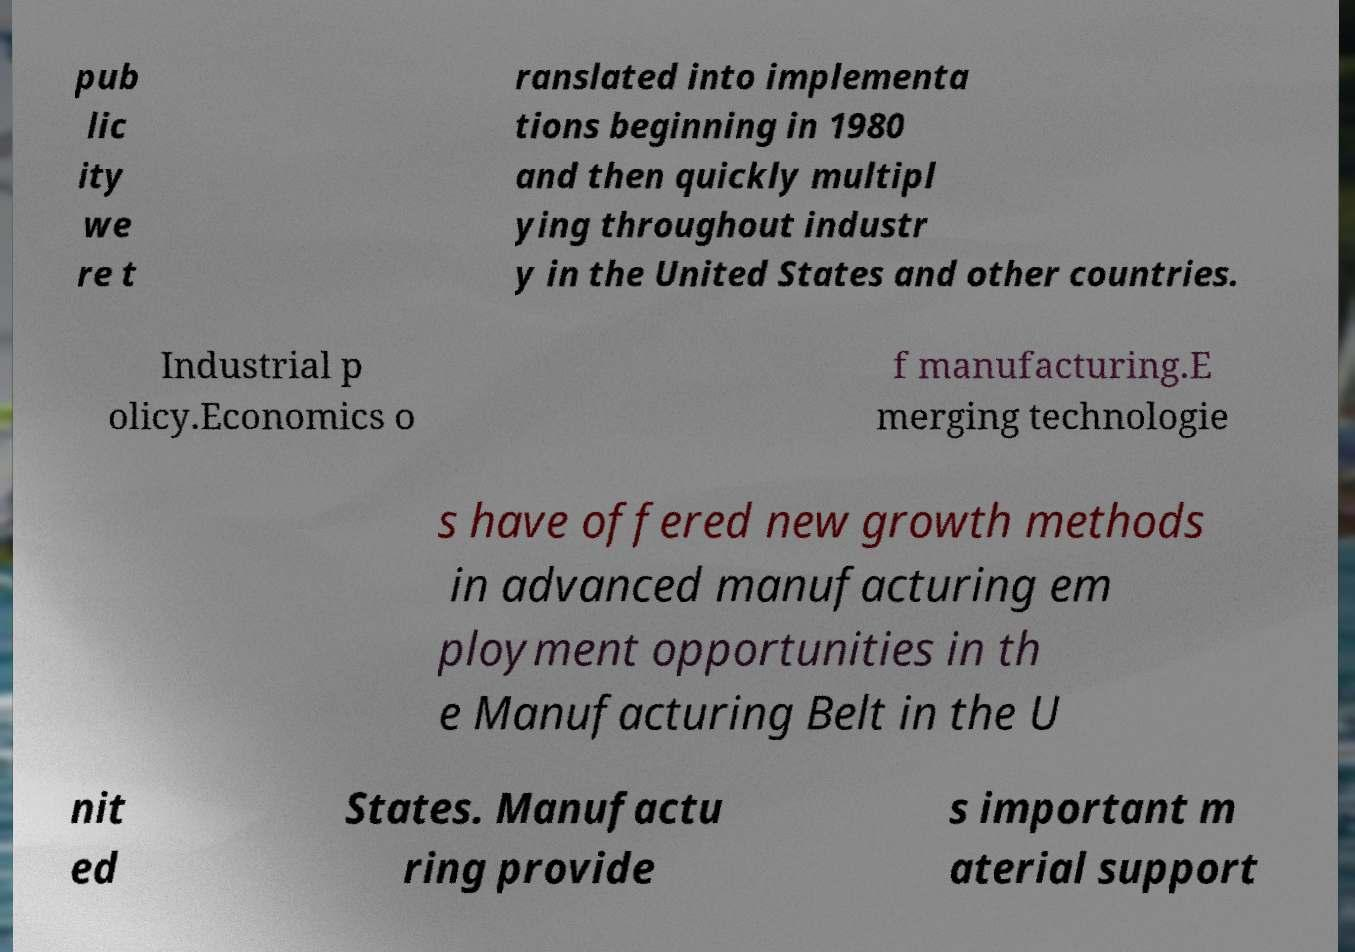Please identify and transcribe the text found in this image. pub lic ity we re t ranslated into implementa tions beginning in 1980 and then quickly multipl ying throughout industr y in the United States and other countries. Industrial p olicy.Economics o f manufacturing.E merging technologie s have offered new growth methods in advanced manufacturing em ployment opportunities in th e Manufacturing Belt in the U nit ed States. Manufactu ring provide s important m aterial support 